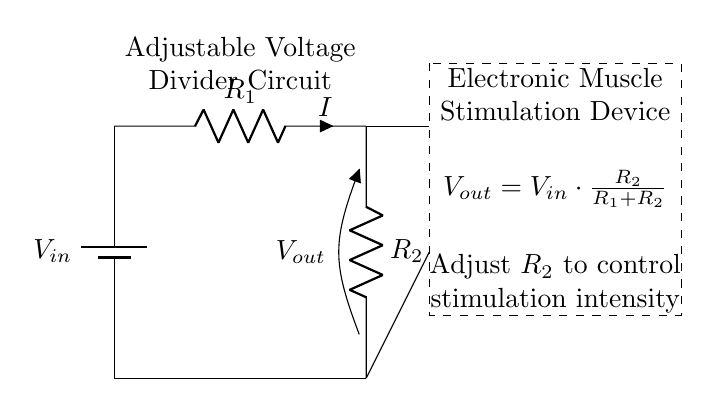What is the purpose of this circuit? The primary purpose of the voltage divider circuit is to adjust the output voltage for controlling the intensity of stimulation in electronic muscle stimulation devices.
Answer: Adjust output voltage What is the formula for Vout? According to the circuit diagram, the output voltage can be calculated using the formula Vout equals Vin times R2 divided by the sum of R1 and R2.
Answer: Vout = Vin * R2 / (R1 + R2) What component is used to adjust the stimulation intensity? The component used to adjust the stimulation intensity is R2, which is adjustable in the circuit.
Answer: R2 What type of devices uses this circuit? This circuit is specifically used in electronic muscle stimulation devices for controlling voltage output.
Answer: Electronic muscle stimulation devices What do the dashed lines represent in the diagram? The dashed lines in the diagram indicate the section where the electronic muscle stimulation device is located, distinguishing it from the voltage divider circuit.
Answer: Electronic Muscle Stimulation Device 